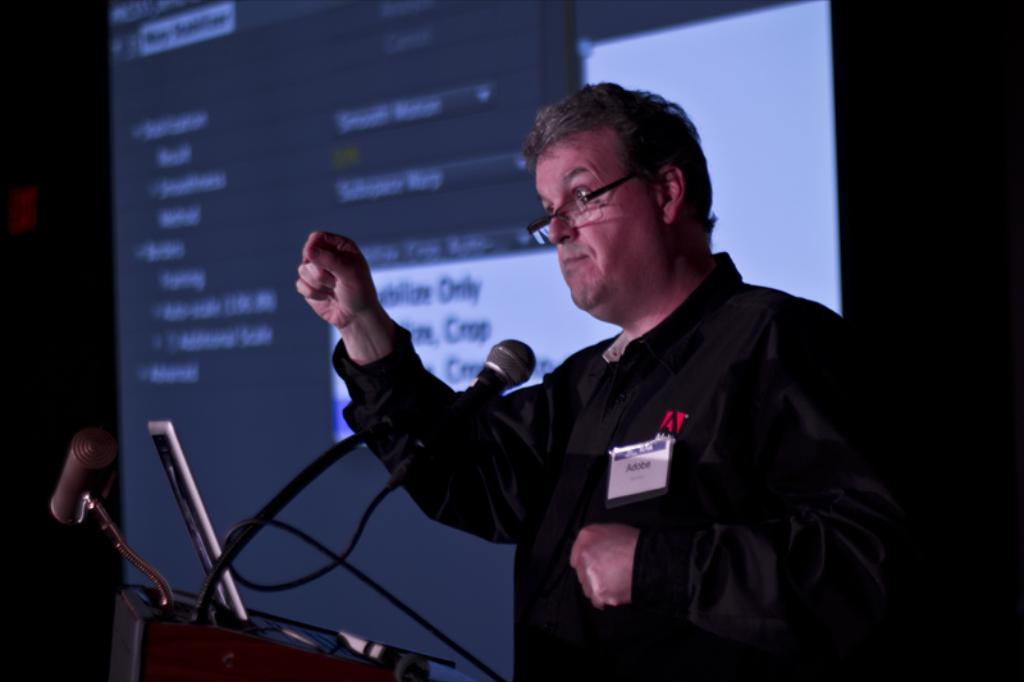What is the main subject of the image? The main subject of the image is a man. Can you describe the man's appearance? The man is wearing clothes and spectacles. What objects are present in the image related to a presentation or speech? There is a microphone, a cable wire, a podium, and a projected screen in the image. What type of flooring can be seen in the image? There is no information about the flooring in the image, as the focus is on the man and the objects related to a presentation or speech. --- Facts: 1. There is a car in the image. 2. The car is red. 3. The car has four wheels. 4. There is a road in the image. 5. The road is paved. 6. There are trees in the background of the image. Absurd Topics: ocean, dinosaur, rainbow Conversation: What is the main subject of the image? The main subject of the image is a car. Can you describe the car's appearance? The car is red and has four wheels. What is the setting of the image? The car is on a road, and there are trees in the background. Can you describe the road in the image? The road is paved. Reasoning: Let's think step by step in order to produce the conversation. We start by identifying the main subject of the image, which is the car. Then, we describe the car's appearance based on the provided facts. Next, we focus on the setting of the image, which includes the road and the trees in the background. Finally, we provide a detail about the road, which is that it is paved. Absurd Question/Answer: Can you see a dinosaur walking on the road in the image? No, there are no dinosaurs present in the image. 